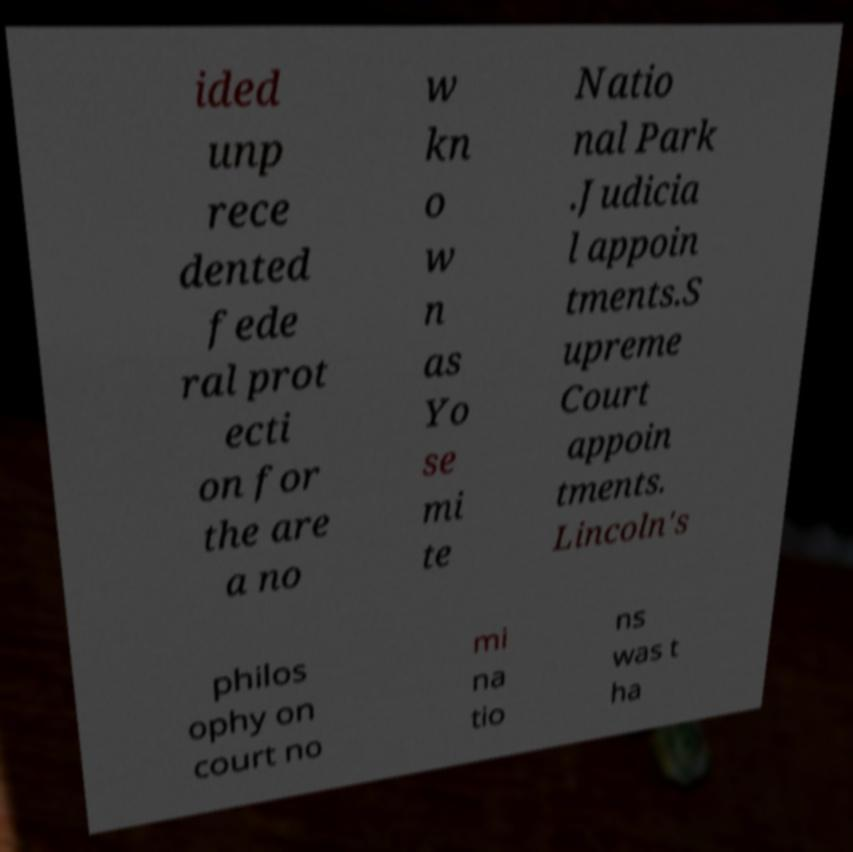There's text embedded in this image that I need extracted. Can you transcribe it verbatim? ided unp rece dented fede ral prot ecti on for the are a no w kn o w n as Yo se mi te Natio nal Park .Judicia l appoin tments.S upreme Court appoin tments. Lincoln's philos ophy on court no mi na tio ns was t ha 